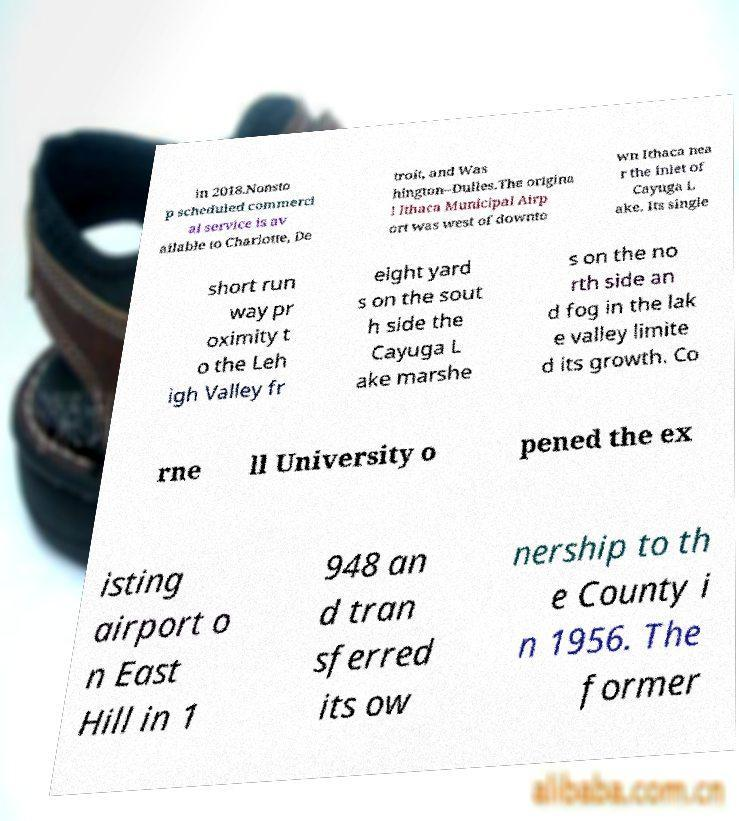Could you assist in decoding the text presented in this image and type it out clearly? in 2018.Nonsto p scheduled commerci al service is av ailable to Charlotte, De troit, and Was hington–Dulles.The origina l Ithaca Municipal Airp ort was west of downto wn Ithaca nea r the inlet of Cayuga L ake. Its single short run way pr oximity t o the Leh igh Valley fr eight yard s on the sout h side the Cayuga L ake marshe s on the no rth side an d fog in the lak e valley limite d its growth. Co rne ll University o pened the ex isting airport o n East Hill in 1 948 an d tran sferred its ow nership to th e County i n 1956. The former 